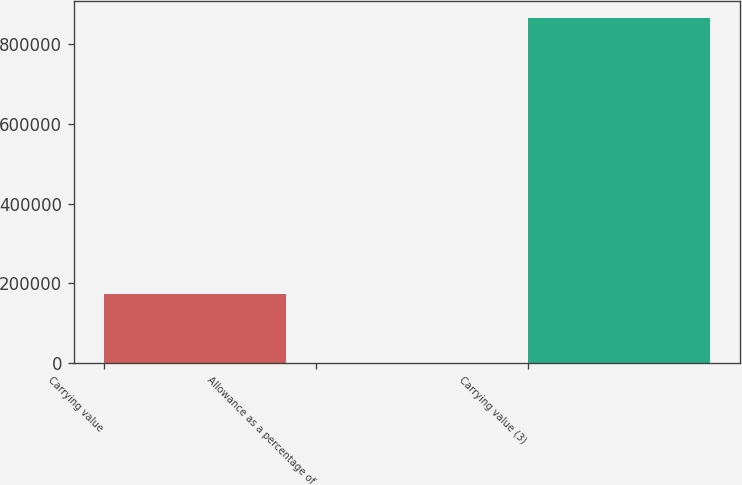<chart> <loc_0><loc_0><loc_500><loc_500><bar_chart><fcel>Carrying value<fcel>Allowance as a percentage of<fcel>Carrying value (3)<nl><fcel>172913<fcel>3.21<fcel>864552<nl></chart> 